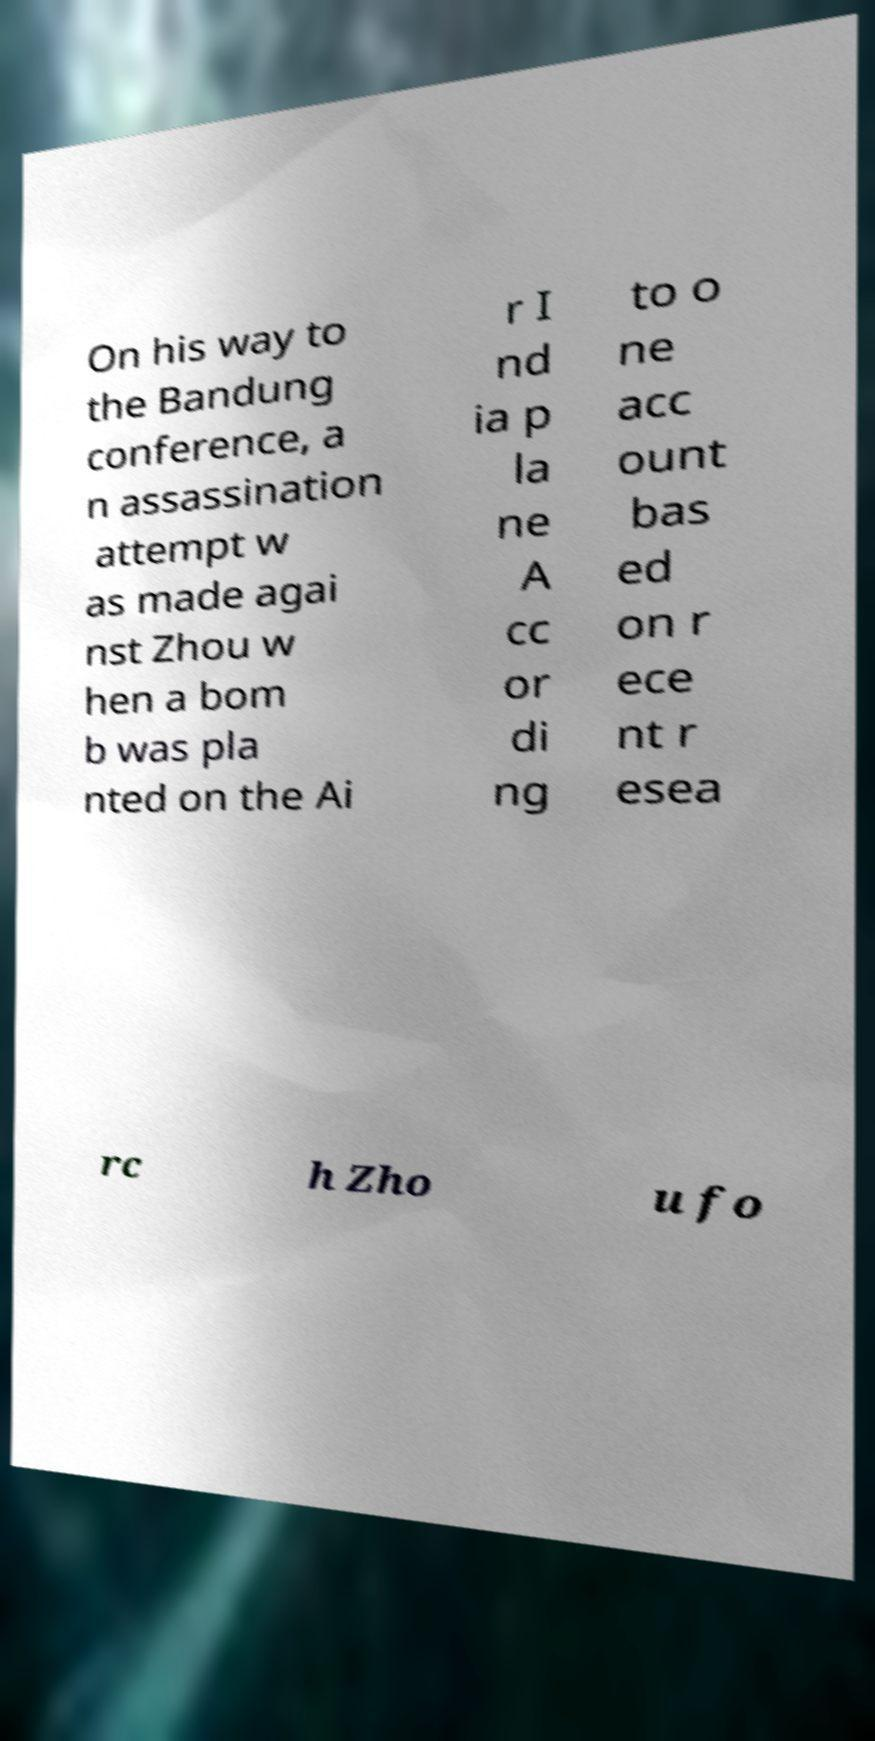Can you read and provide the text displayed in the image?This photo seems to have some interesting text. Can you extract and type it out for me? On his way to the Bandung conference, a n assassination attempt w as made agai nst Zhou w hen a bom b was pla nted on the Ai r I nd ia p la ne A cc or di ng to o ne acc ount bas ed on r ece nt r esea rc h Zho u fo 